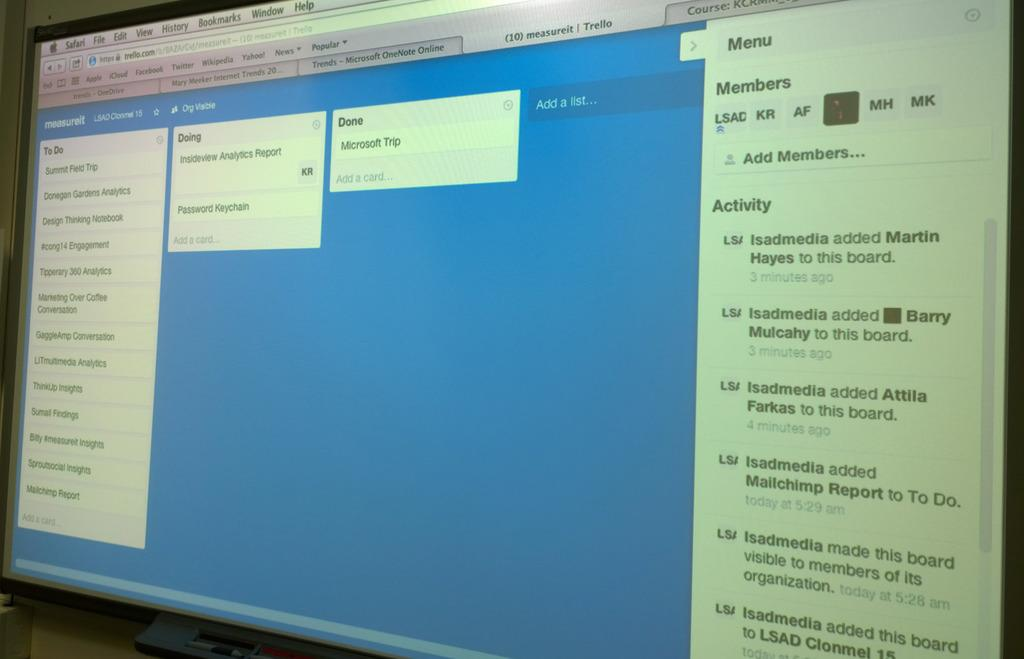<image>
Write a terse but informative summary of the picture. A computer screen shows a to do list, a doing list, and a done list. 